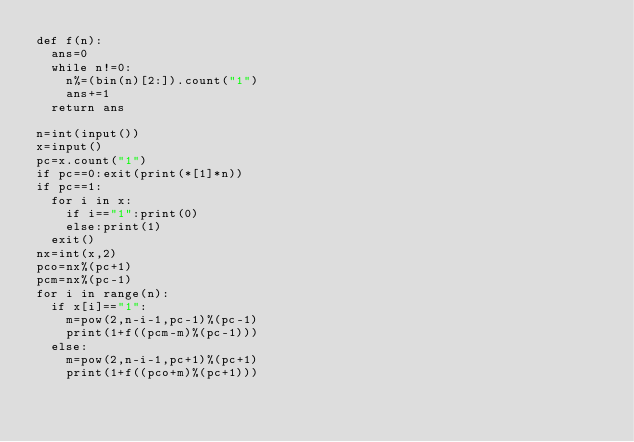<code> <loc_0><loc_0><loc_500><loc_500><_Python_>def f(n):
  ans=0
  while n!=0:
    n%=(bin(n)[2:]).count("1")
    ans+=1
  return ans

n=int(input())
x=input()
pc=x.count("1")
if pc==0:exit(print(*[1]*n))
if pc==1:
  for i in x:
    if i=="1":print(0)
    else:print(1)
  exit()
nx=int(x,2)
pco=nx%(pc+1)
pcm=nx%(pc-1)
for i in range(n):
  if x[i]=="1":
    m=pow(2,n-i-1,pc-1)%(pc-1)
    print(1+f((pcm-m)%(pc-1)))
  else:
    m=pow(2,n-i-1,pc+1)%(pc+1)
    print(1+f((pco+m)%(pc+1)))
</code> 